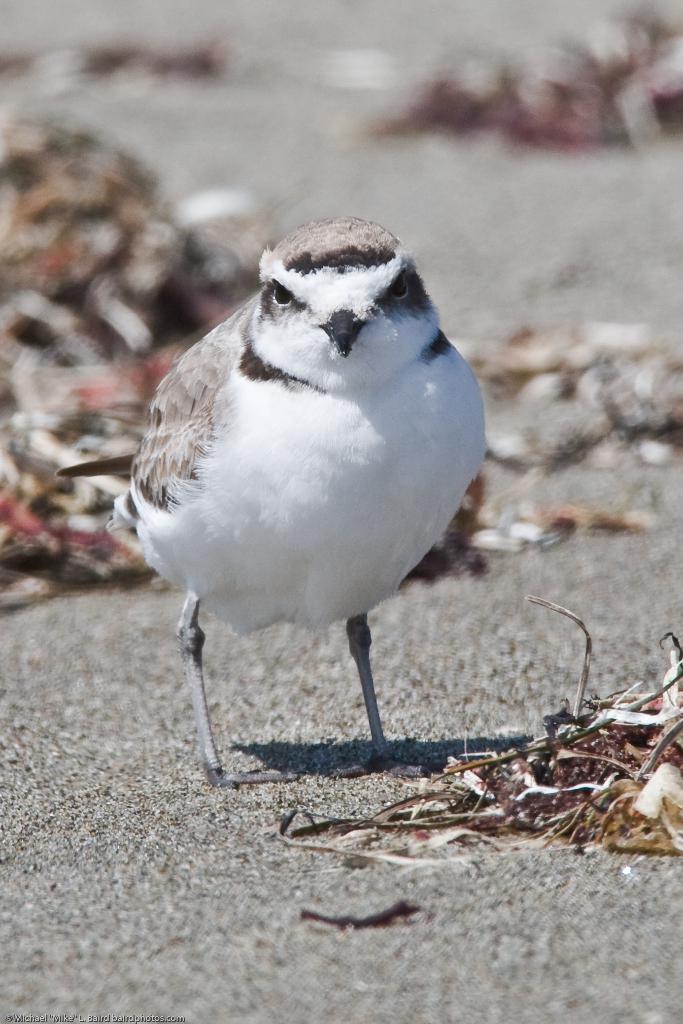Can you describe this image briefly? In this picture I can see there is a bird and there are twigs and dry leaves on the floor. 